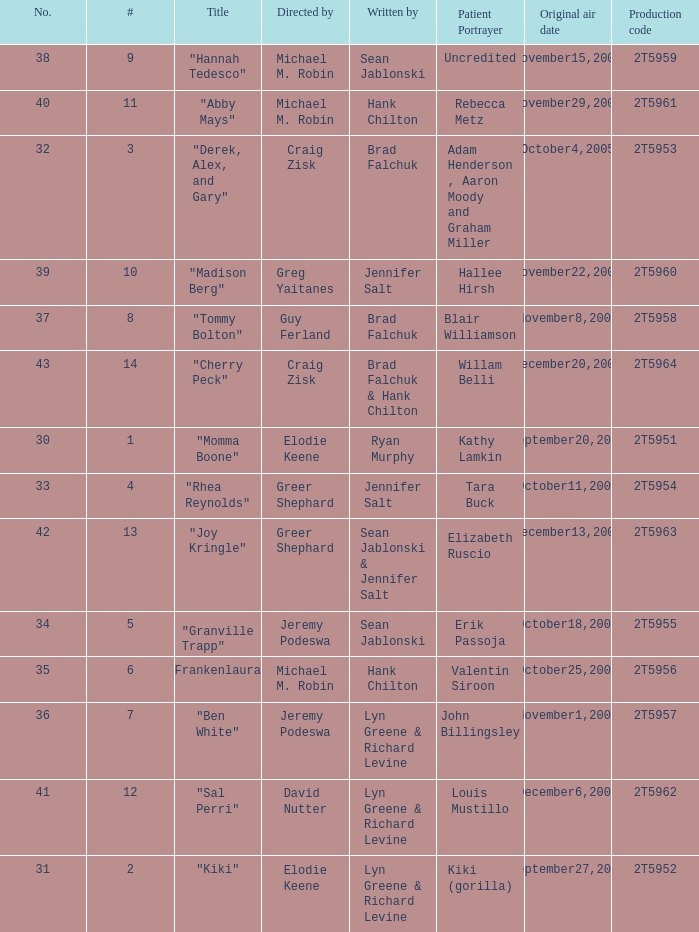Who was the writter for the  episode identified by the production code 2t5954? Jennifer Salt. Parse the full table. {'header': ['No.', '#', 'Title', 'Directed by', 'Written by', 'Patient Portrayer', 'Original air date', 'Production code'], 'rows': [['38', '9', '"Hannah Tedesco"', 'Michael M. Robin', 'Sean Jablonski', 'Uncredited', 'November15,2005', '2T5959'], ['40', '11', '"Abby Mays"', 'Michael M. Robin', 'Hank Chilton', 'Rebecca Metz', 'November29,2005', '2T5961'], ['32', '3', '"Derek, Alex, and Gary"', 'Craig Zisk', 'Brad Falchuk', 'Adam Henderson , Aaron Moody and Graham Miller', 'October4,2005', '2T5953'], ['39', '10', '"Madison Berg"', 'Greg Yaitanes', 'Jennifer Salt', 'Hallee Hirsh', 'November22,2005', '2T5960'], ['37', '8', '"Tommy Bolton"', 'Guy Ferland', 'Brad Falchuk', 'Blair Williamson', 'November8,2005', '2T5958'], ['43', '14', '"Cherry Peck"', 'Craig Zisk', 'Brad Falchuk & Hank Chilton', 'Willam Belli', 'December20,2005', '2T5964'], ['30', '1', '"Momma Boone"', 'Elodie Keene', 'Ryan Murphy', 'Kathy Lamkin', 'September20,2005', '2T5951'], ['33', '4', '"Rhea Reynolds"', 'Greer Shephard', 'Jennifer Salt', 'Tara Buck', 'October11,2005', '2T5954'], ['42', '13', '"Joy Kringle"', 'Greer Shephard', 'Sean Jablonski & Jennifer Salt', 'Elizabeth Ruscio', 'December13,2005', '2T5963'], ['34', '5', '"Granville Trapp"', 'Jeremy Podeswa', 'Sean Jablonski', 'Erik Passoja', 'October18,2005', '2T5955'], ['35', '6', '"Frankenlaura"', 'Michael M. Robin', 'Hank Chilton', 'Valentin Siroon', 'October25,2005', '2T5956'], ['36', '7', '"Ben White"', 'Jeremy Podeswa', 'Lyn Greene & Richard Levine', 'John Billingsley', 'November1,2005', '2T5957'], ['41', '12', '"Sal Perri"', 'David Nutter', 'Lyn Greene & Richard Levine', 'Louis Mustillo', 'December6,2005', '2T5962'], ['31', '2', '"Kiki"', 'Elodie Keene', 'Lyn Greene & Richard Levine', 'Kiki (gorilla)', 'September27,2005', '2T5952']]} 